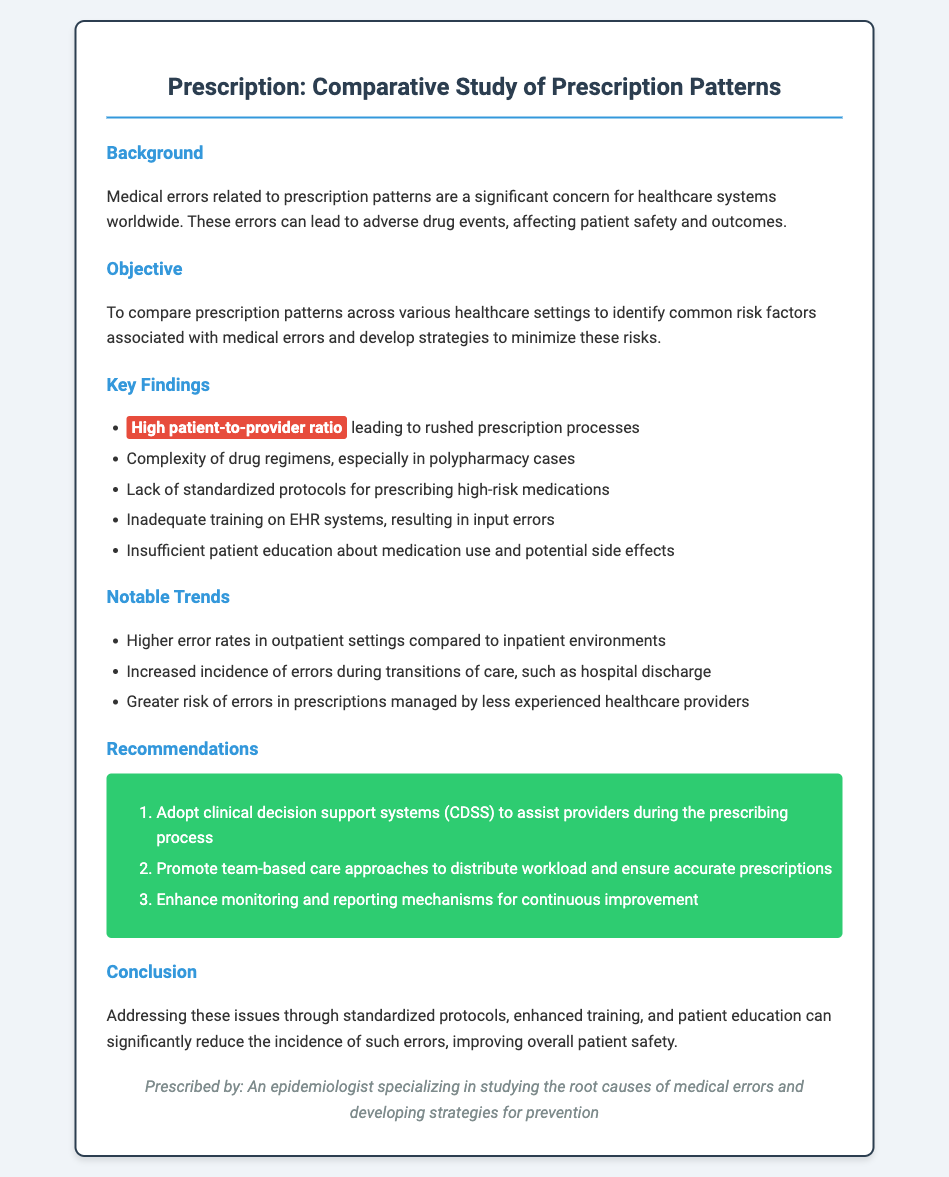What is the primary concern addressed in the study? The primary concern is related to medical errors in prescription patterns, which affect patient safety and outcomes.
Answer: medical errors What is the objective of the comparative study? The objective is to compare prescription patterns across healthcare settings to identify risk factors for medical errors.
Answer: compare prescription patterns What factor increases the likelihood of rushed prescriptions? A high patient-to-provider ratio leads to rushed prescription processes.
Answer: high patient-to-provider ratio What setting has higher error rates according to the findings? Higher error rates are noted in outpatient settings compared to inpatient environments.
Answer: outpatient settings Which recommendation involves technology to assist providers? The recommendation to adopt clinical decision support systems (CDSS) assists providers during the prescribing process.
Answer: clinical decision support systems (CDSS) What issue arises during transitions of care according to notable trends? Increased incidence of errors occurs during transitions of care, such as hospital discharge.
Answer: transitions of care How many recommendations are made in the document? There are three recommendations provided to address medical errors and improve prescription practices.
Answer: three recommendations What is the suggested approach to distribute workload amongst providers? The document recommends promoting team-based care approaches to distribute workload.
Answer: team-based care approaches 